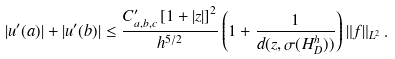Convert formula to latex. <formula><loc_0><loc_0><loc_500><loc_500>| u ^ { \prime } ( a ) | + | u ^ { \prime } ( b ) | \leq \frac { C ^ { \prime } _ { a , b , c } \left [ 1 + | z | \right ] ^ { 2 } } { h ^ { 5 / 2 } } \left ( 1 + \frac { 1 } { d ( z , \sigma ( H _ { D } ^ { h } ) ) } \right ) \| f \| _ { L ^ { 2 } } \, .</formula> 